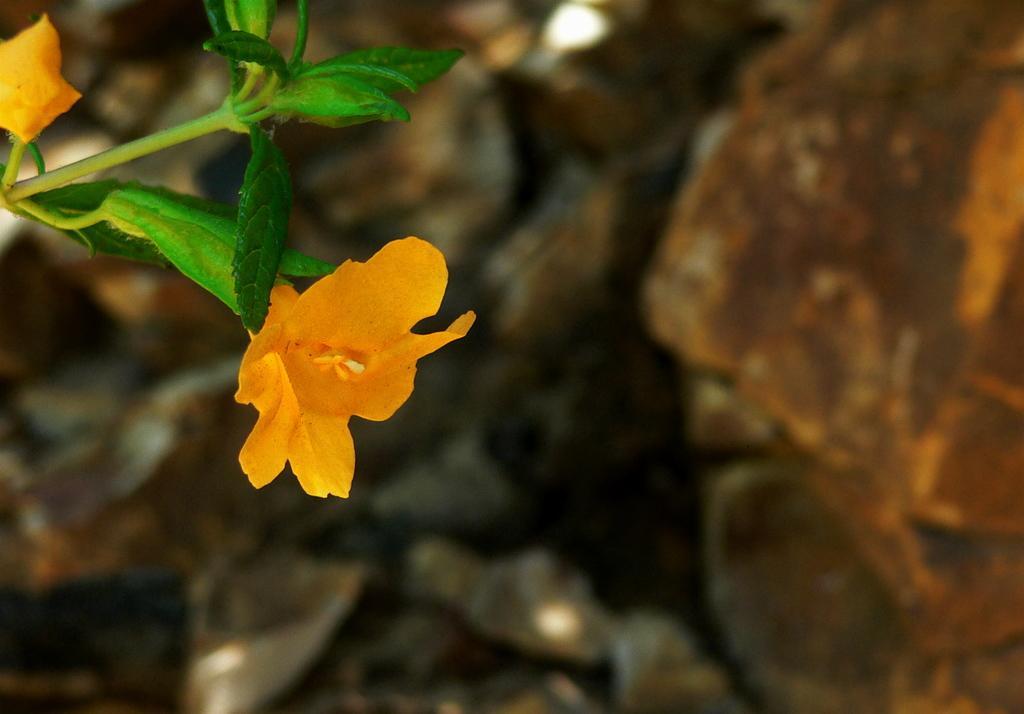Can you describe this image briefly? In this image there are flowers along with leaves and the background is blurry. 